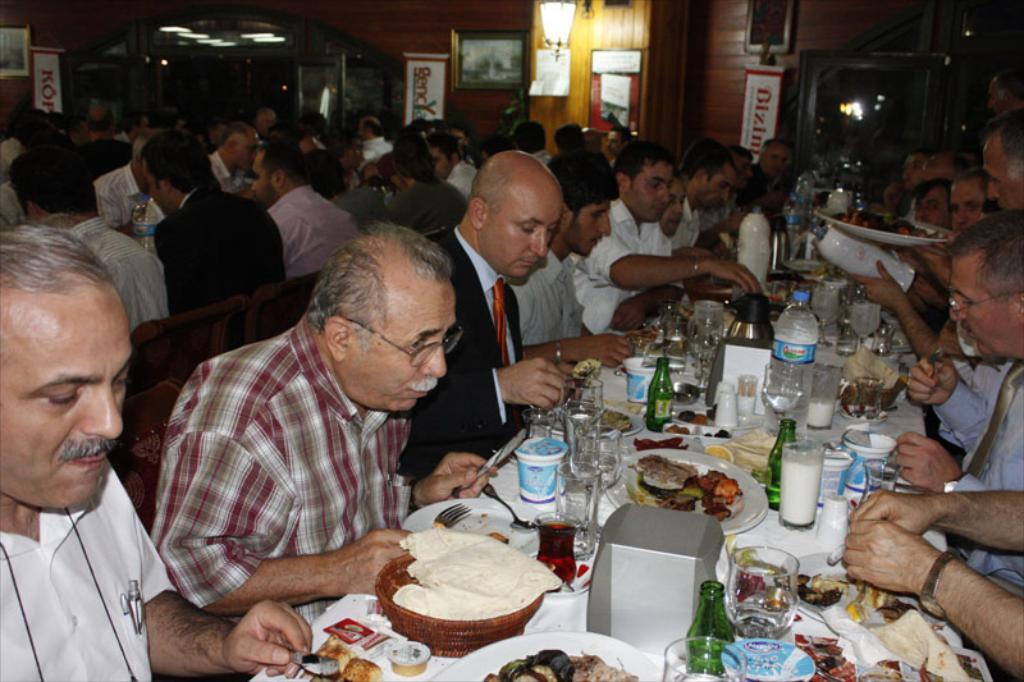What are the people in the image doing? The people in the image are sitting on chairs. What objects can be seen on the table in the image? There are glasses, bottles, cups, and food on the table in the image. What type of ship can be seen sailing in the background of the image? There is no ship visible in the image; it only shows people sitting on chairs and objects on a table. 